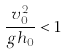Convert formula to latex. <formula><loc_0><loc_0><loc_500><loc_500>\frac { v _ { 0 } ^ { 2 } } { g h _ { 0 } } < 1</formula> 